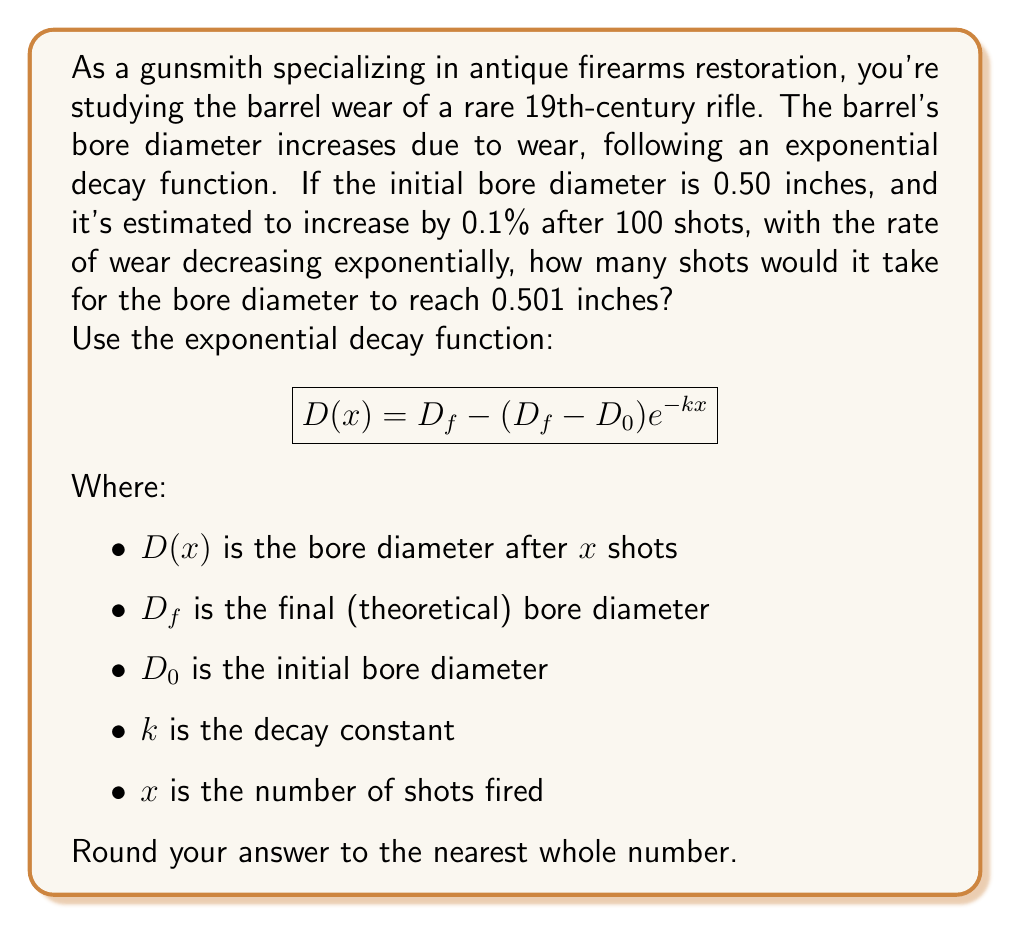Show me your answer to this math problem. Let's approach this step-by-step:

1) We know:
   $D_0 = 0.50$ inches (initial diameter)
   After 100 shots, the diameter increases by 0.1%
   $D(100) = 0.50 * 1.001 = 0.5005$ inches

2) We need to find $k$ and $D_f$. Let's start with $k$:

   $$0.5005 = D_f - (D_f - 0.50)e^{-100k}$$

3) We don't know $D_f$, but we know it's slightly larger than 0.5005. Let's estimate it as 0.501:

   $$0.5005 = 0.501 - (0.001)e^{-100k}$$

4) Solving for $k$:

   $$0.0005 = 0.001(1 - e^{-100k})$$
   $$0.5 = 1 - e^{-100k}$$
   $$e^{-100k} = 0.5$$
   $$-100k = \ln(0.5)$$
   $$k = -\frac{\ln(0.5)}{100} \approx 0.00693$$

5) Now we can use the original function to find $x$ when $D(x) = 0.501$:

   $$0.501 = 0.501 - (0.001)e^{-0.00693x}$$

6) Solving for $x$:

   $$0.001e^{-0.00693x} = 0$$
   $$e^{-0.00693x} = 0$$
   $$-0.00693x = \ln(0)$$

   This is impossible, as $\ln(0)$ is undefined. This means the bore will asymptotically approach 0.501 inches but never quite reach it.

7) Instead, let's solve for when the bore reaches 0.50099 inches (very close to 0.501):

   $$0.50099 = 0.501 - (0.001)e^{-0.00693x}$$
   $$0.00001 = (0.001)e^{-0.00693x}$$
   $$0.01 = e^{-0.00693x}$$
   $$\ln(0.01) = -0.00693x$$
   $$x = \frac{\ln(0.01)}{-0.00693} \approx 663.7$$

Therefore, it would take approximately 664 shots for the bore diameter to reach 0.50099 inches, which is very close to 0.501 inches.
Answer: 664 shots 